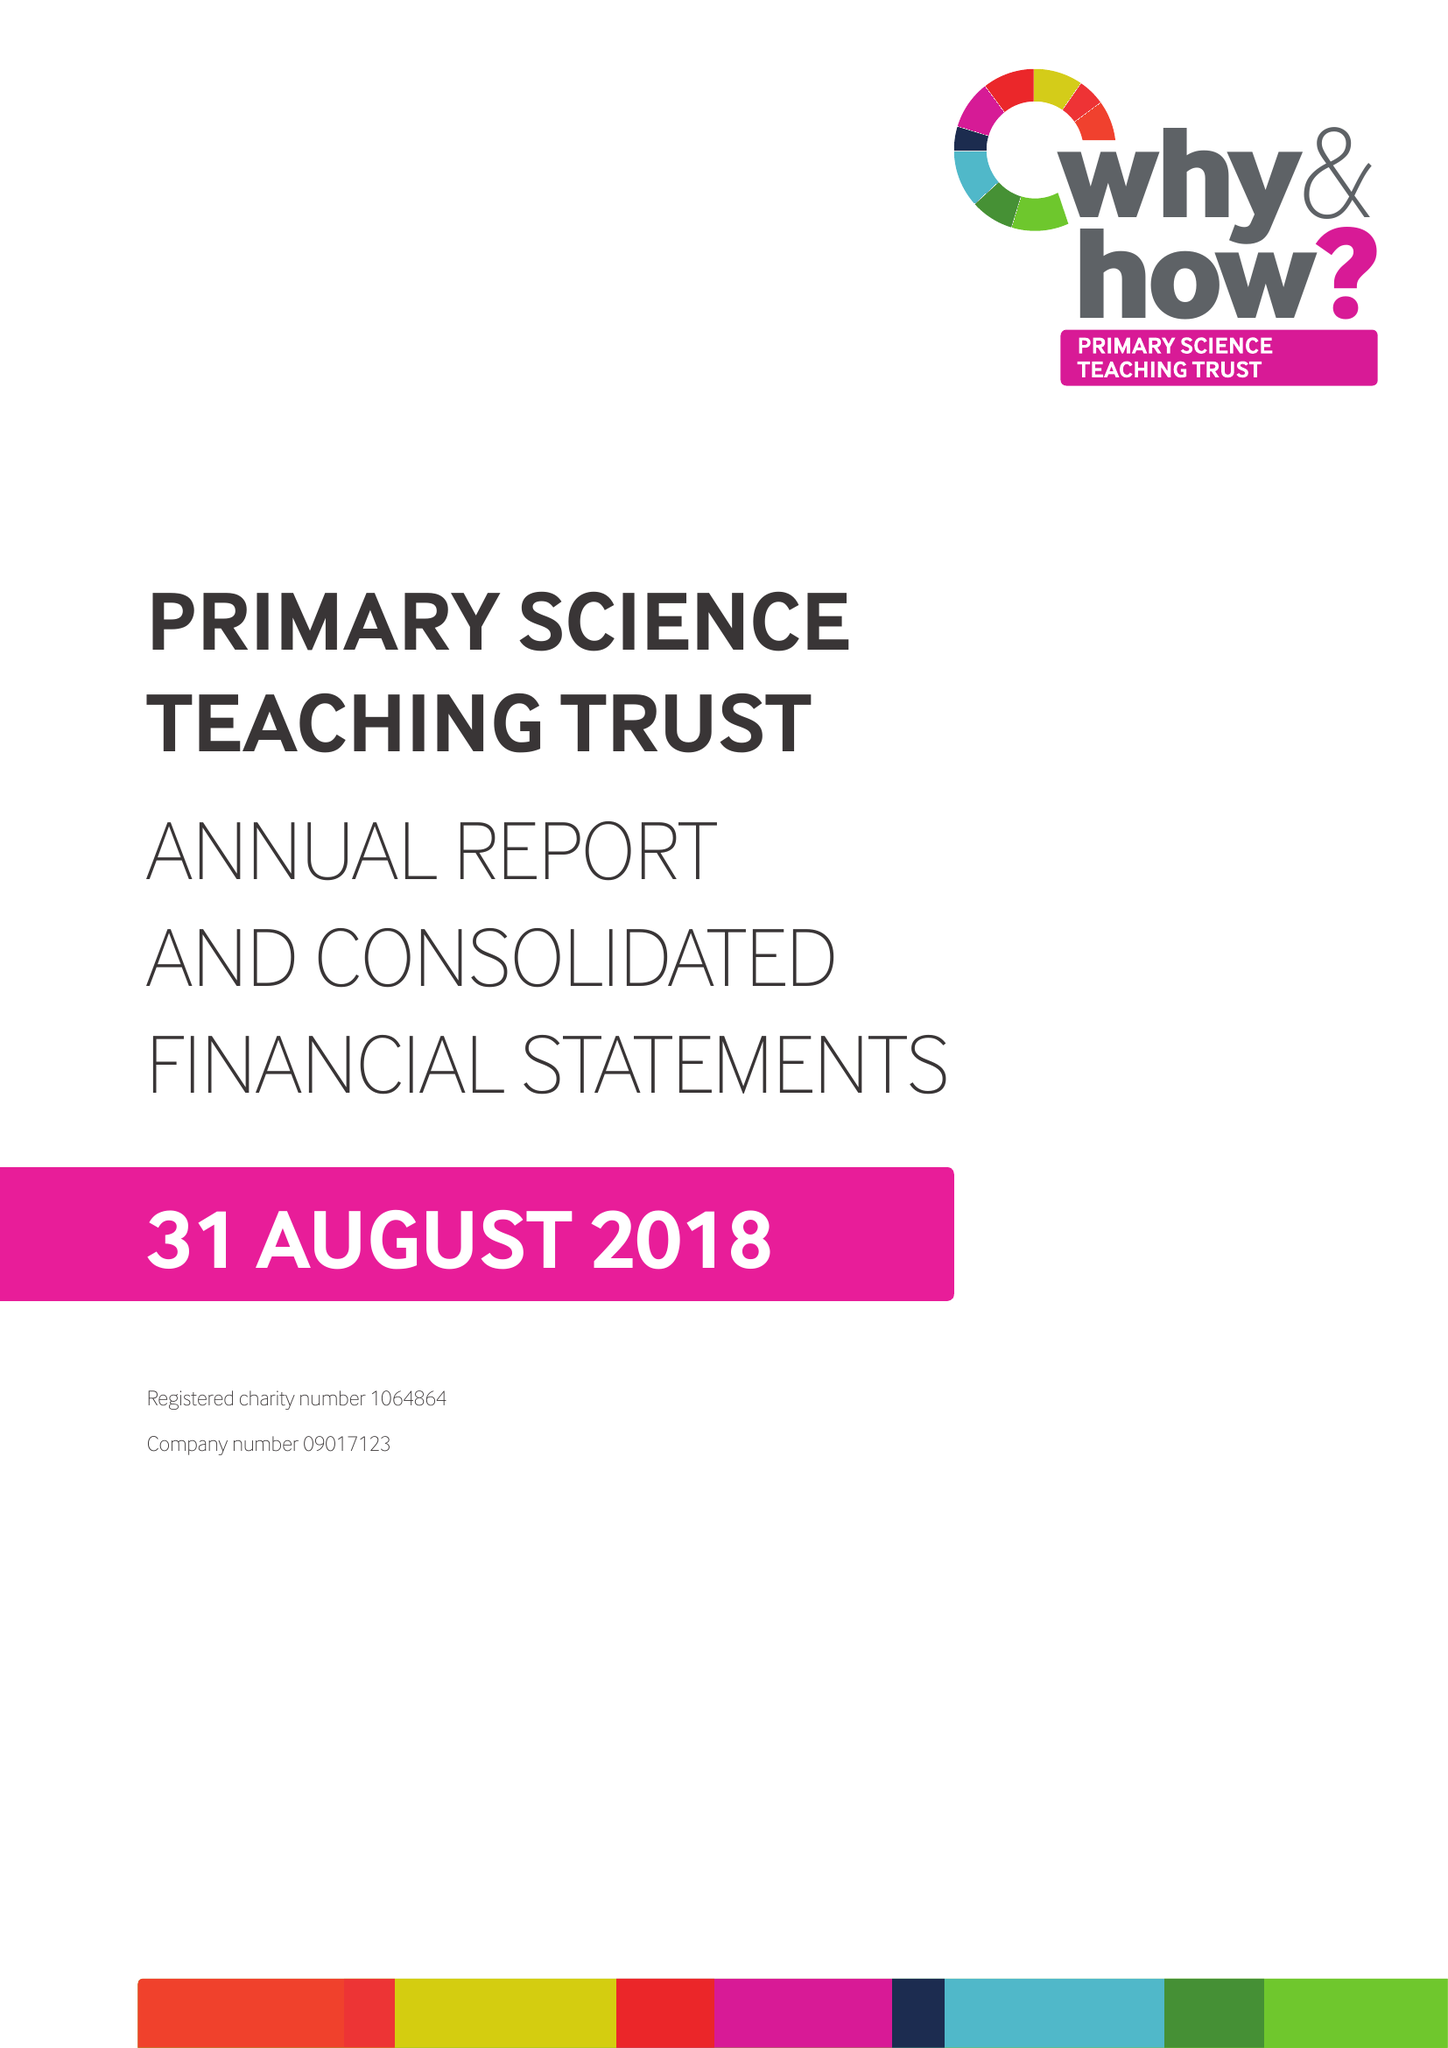What is the value for the report_date?
Answer the question using a single word or phrase. 2018-08-31 